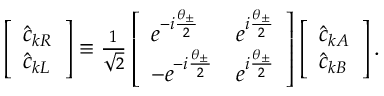Convert formula to latex. <formula><loc_0><loc_0><loc_500><loc_500>\begin{array} { r } { \left [ \begin{array} { l } { \hat { c } _ { k R } } \\ { \hat { c } _ { k L } } \end{array} \right ] \equiv \frac { 1 } { \sqrt { 2 } } \left [ \begin{array} { l l } { e ^ { - i \frac { \theta _ { \pm } } { 2 } } } & { e ^ { i \frac { \theta _ { \pm } } { 2 } } } \\ { - e ^ { - i \frac { \theta _ { \pm } } { 2 } } } & { e ^ { i \frac { \theta _ { \pm } } { 2 } } } \end{array} \right ] \left [ \begin{array} { l } { \hat { c } _ { k A } } \\ { \hat { c } _ { k B } } \end{array} \right ] . } \end{array}</formula> 